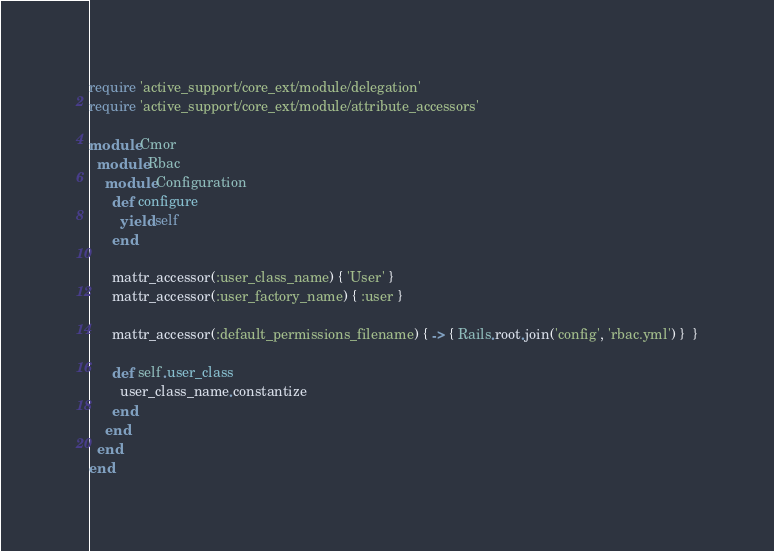Convert code to text. <code><loc_0><loc_0><loc_500><loc_500><_Ruby_>require 'active_support/core_ext/module/delegation'
require 'active_support/core_ext/module/attribute_accessors'

module Cmor
  module Rbac
    module Configuration
      def configure
        yield self
      end

      mattr_accessor(:user_class_name) { 'User' }
      mattr_accessor(:user_factory_name) { :user }

      mattr_accessor(:default_permissions_filename) { -> { Rails.root.join('config', 'rbac.yml') }  }

      def self.user_class
        user_class_name.constantize
      end
    end
  end
end</code> 